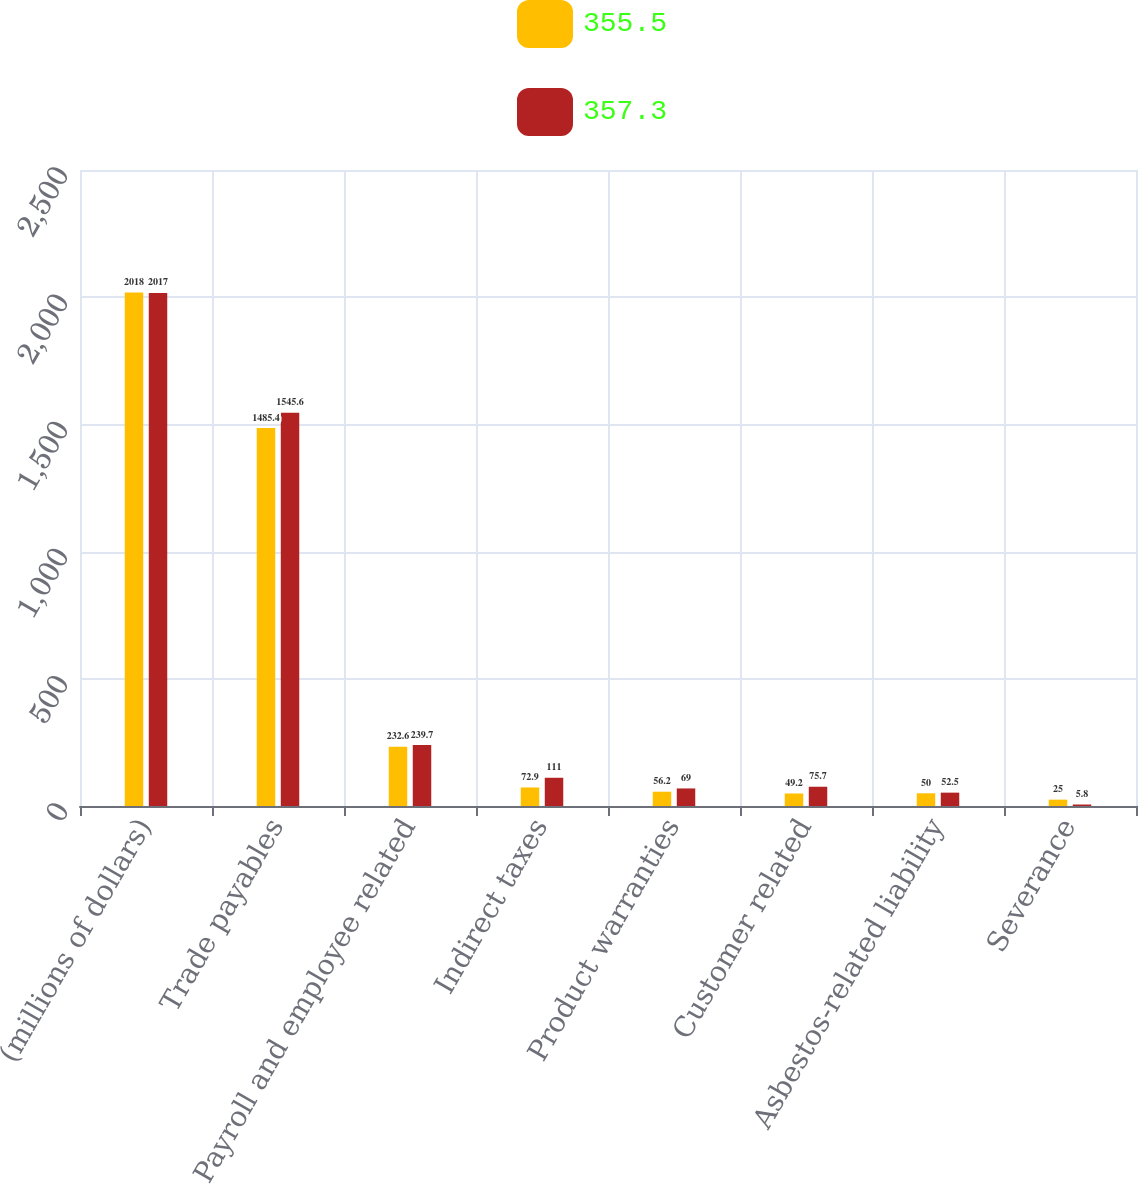Convert chart. <chart><loc_0><loc_0><loc_500><loc_500><stacked_bar_chart><ecel><fcel>(millions of dollars)<fcel>Trade payables<fcel>Payroll and employee related<fcel>Indirect taxes<fcel>Product warranties<fcel>Customer related<fcel>Asbestos-related liability<fcel>Severance<nl><fcel>355.5<fcel>2018<fcel>1485.4<fcel>232.6<fcel>72.9<fcel>56.2<fcel>49.2<fcel>50<fcel>25<nl><fcel>357.3<fcel>2017<fcel>1545.6<fcel>239.7<fcel>111<fcel>69<fcel>75.7<fcel>52.5<fcel>5.8<nl></chart> 